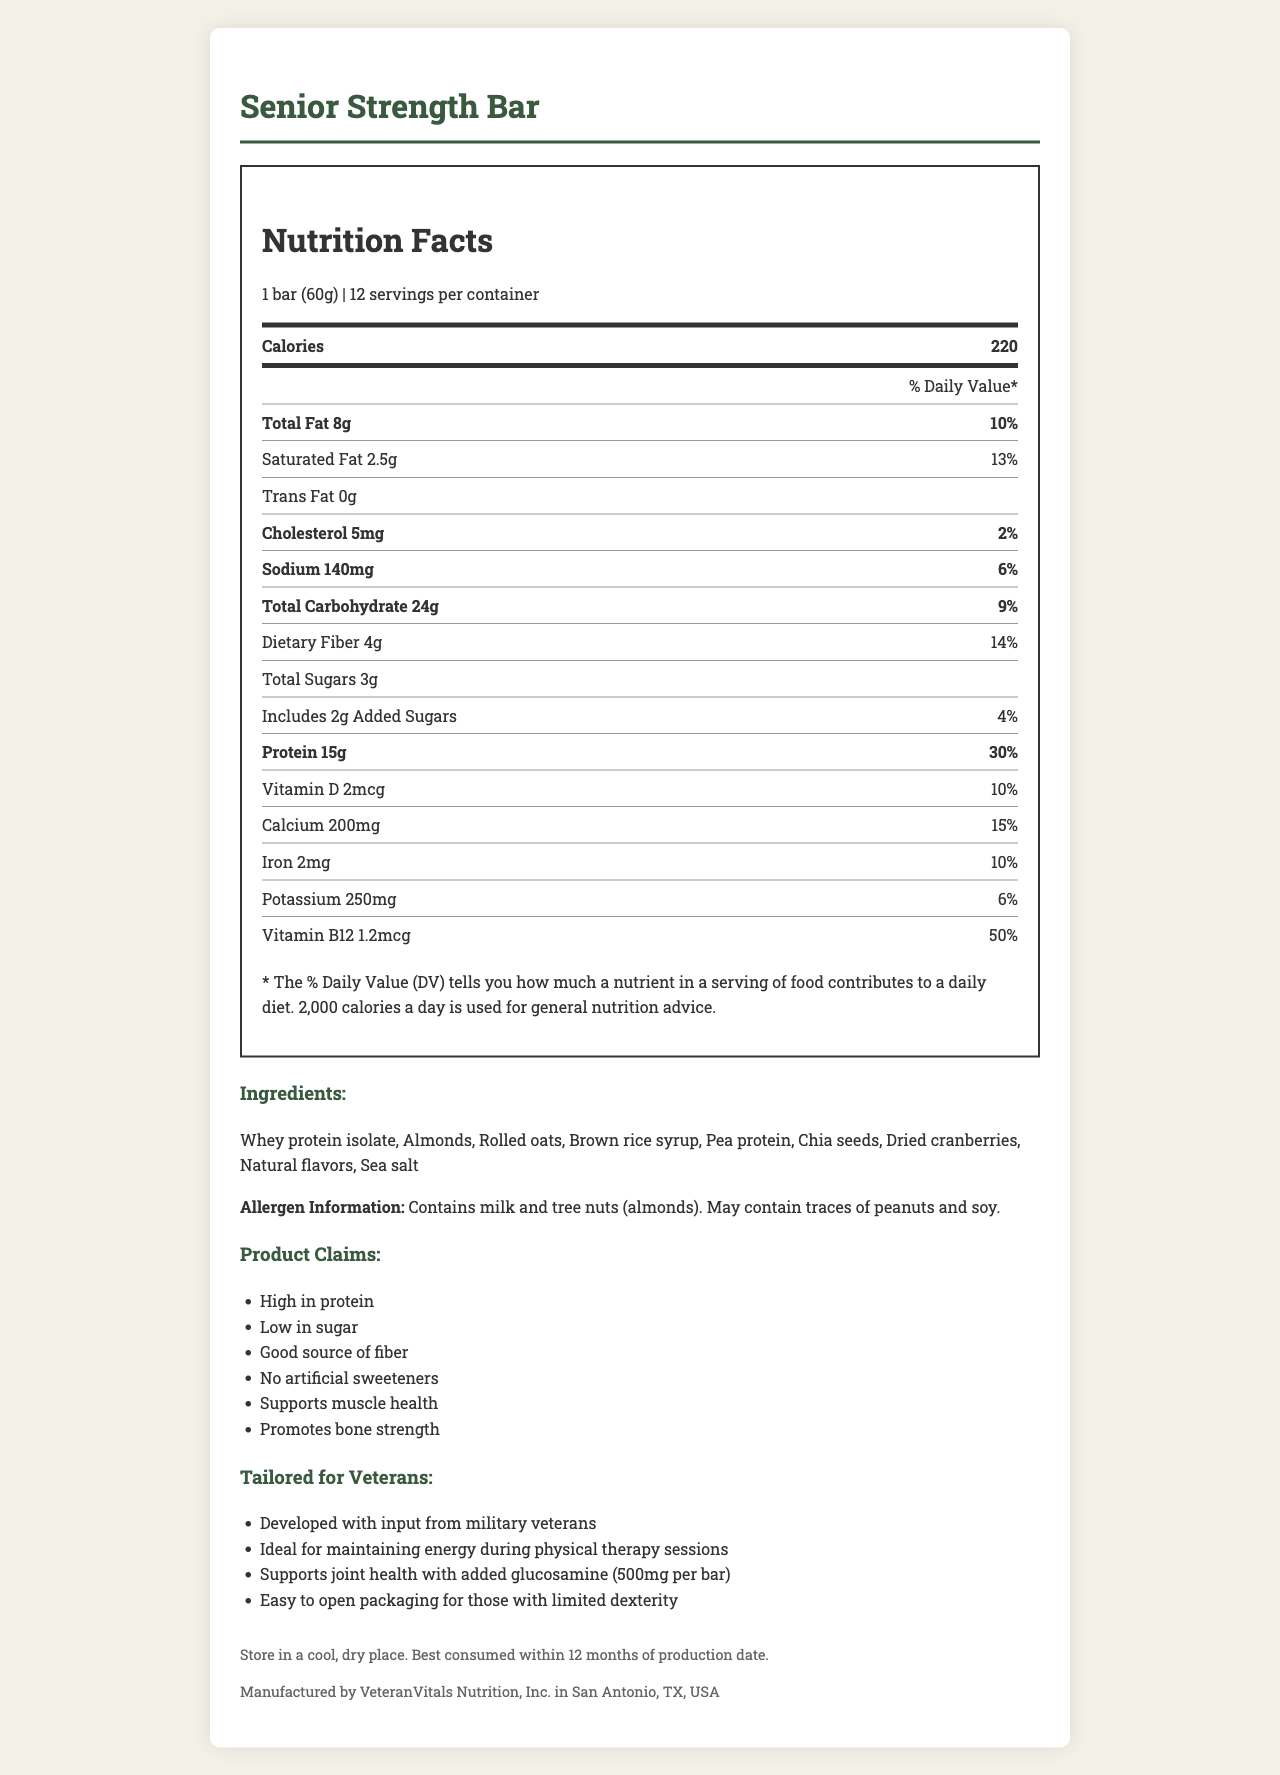What is the serving size of the Senior Strength Bar? The serving size is listed at the top of the Nutrition Facts panel and states "1 bar (60g)".
Answer: 1 bar (60g) How many calories are in one serving of the Senior Strength Bar? The number of calories per serving is listed prominently in the Nutrition Facts panel as "Calories 220".
Answer: 220 What is the percentage of daily value for protein in one bar? The daily value percentage for protein is given as "30%" in the Nutrition Facts panel under protein amount.
Answer: 30% List the primary allergens found in the Senior Strength Bar. The allergen information is listed in its dedicated section and indicates that the bar contains milk and tree nuts (almonds).
Answer: Milk and tree nuts (almonds) What is the total amount of dietary fiber in one serving? The amount of dietary fiber is provided in the Nutrition Facts and is stated as "4g".
Answer: 4g What is the serving size? A. 2 bars (120g) B. 1 bar (60g) C. Half a bar (30g) D. 1.5 bars (90g) The serving size is specified at the top of the Nutrition Facts label as "1 bar (60g)".
Answer: B Which of the following nutrients is highest in percentage of daily value? I. Cholesterol II. Dietary Fiber III. Sodium IV. Vitamin B12 The daily values provided show Vitamin B12 at 50%, which is the highest among the listed options.
Answer: IV. Vitamin B12 Does this product contain any artificial sweeteners? The product claims explicitly state "No artificial sweeteners".
Answer: No Summarize the main idea of the document. The document gives a comprehensive overview of the Senior Strength Bar, including its nutrition facts, ingredients, allergen information, product claims, tailored information for veterans, storage instructions, and manufacturing details.
Answer: The document details the nutritional information, claims, ingredient list, and tailored features of the Senior Strength Bar, a high-protein, low-sugar energy bar designed for active seniors, particularly veterans. How much potassium is in one serving? The amount of potassium is listed in the Nutrition Facts panel as "250mg".
Answer: 250mg What is the company that manufactures the Senior Strength Bar? The manufacturing company is provided in the footer section as "Manufactured by VeteranVitals Nutrition, Inc.".
Answer: VeteranVitals Nutrition, Inc. Where is the Senior Strength Bar manufactured? A. Austin, TX B. San Diego, CA C. San Antonio, TX D. Denver, CO The manufacturing location is listed in the footer as "San Antonio, TX, USA".
Answer: C How much glucosamine is added per bar to support joint health? The tailored information section specifies that each bar contains "500mg per bar" of glucosamine to support joint health.
Answer: 500mg List any ingredients that might contain traces of peanuts and soy. The allergen information states that the product "may contain traces of peanuts and soy".
Answer: May contain traces of peanuts and soy. How many bars are there in one container? The servings per container is listed at the top of the Nutrition Facts panel as "12".
Answer: 12 Does this bar support bone strength? One of the product claims listed is "Promotes bone strength".
Answer: Yes How much vitamin D is in one bar? The amount of vitamin D is specified in the Nutrition Facts panel as "2mcg".
Answer: 2mcg What is not mentioned about the bar's taste? The document does not provide specific information about the taste of the Senior Strength Bar.
Answer: Not enough information What is the daily value percentage of added sugars in the Senior Strength Bar? The daily value percentage for added sugars is listed in the Nutrition Facts panel as "4%".
Answer: 4% 